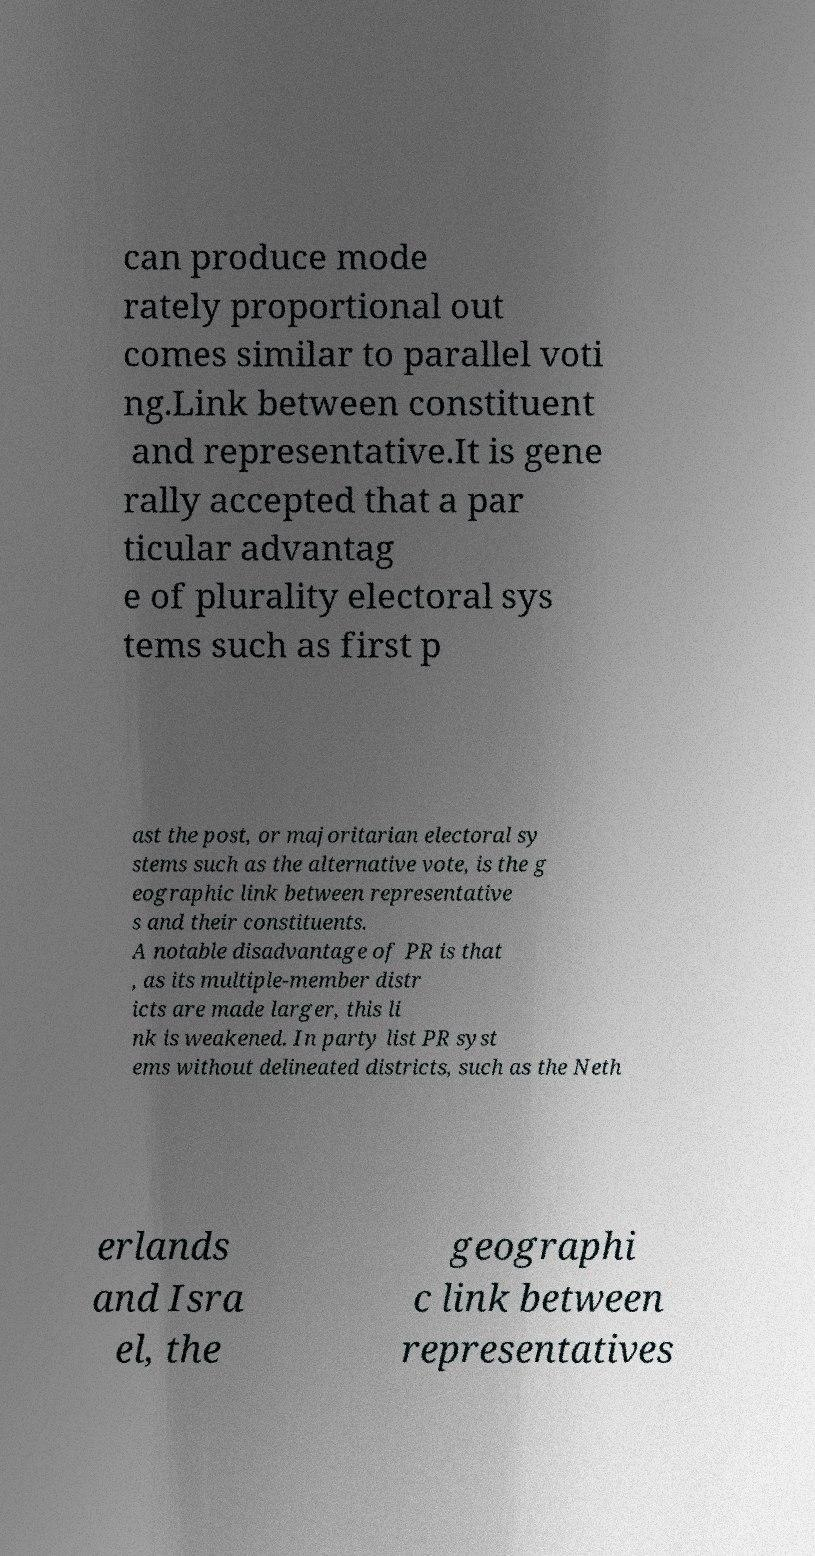Please identify and transcribe the text found in this image. can produce mode rately proportional out comes similar to parallel voti ng.Link between constituent and representative.It is gene rally accepted that a par ticular advantag e of plurality electoral sys tems such as first p ast the post, or majoritarian electoral sy stems such as the alternative vote, is the g eographic link between representative s and their constituents. A notable disadvantage of PR is that , as its multiple-member distr icts are made larger, this li nk is weakened. In party list PR syst ems without delineated districts, such as the Neth erlands and Isra el, the geographi c link between representatives 